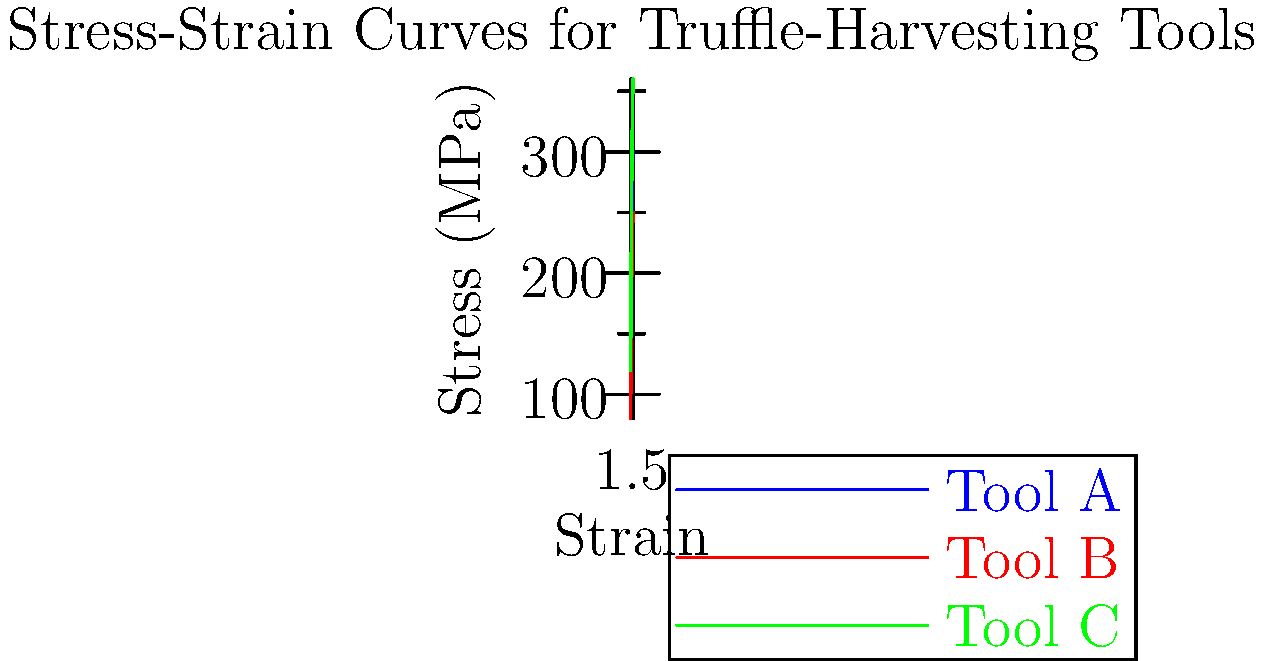Based on the stress-strain curves shown for three different truffle-harvesting tools, which tool exhibits the highest tensile strength and would be most suitable for harvesting the delicate Périgord black truffle? To determine which tool has the highest tensile strength and is most suitable for harvesting delicate truffles, we need to analyze the stress-strain curves:

1. Tensile strength is typically measured by the maximum stress a material can withstand before failure.

2. In the graph:
   - Tool A (blue): Max stress ≈ 300 MPa
   - Tool B (red): Max stress ≈ 250 MPa
   - Tool C (green): Max stress ≈ 360 MPa

3. Tool C has the highest maximum stress, indicating the highest tensile strength.

4. However, for harvesting delicate truffles, we also need to consider:
   - Initial slope (stiffness): Tool C has the steepest initial slope, indicating high stiffness.
   - Ductility: Tool A and B show more gradual curves, suggesting higher ductility.

5. For delicate Périgord black truffles:
   - High tensile strength ensures the tool won't break during use.
   - Some ductility is desirable to prevent damaging the truffles.
   - Moderate stiffness provides control without being too rigid.

6. Balancing these factors, Tool A offers a good compromise:
   - High tensile strength (300 MPa)
   - Moderate stiffness
   - Good ductility

Therefore, while Tool C has the highest tensile strength, Tool A would be most suitable for harvesting delicate Périgord black truffles due to its balanced properties.
Answer: Tool A 